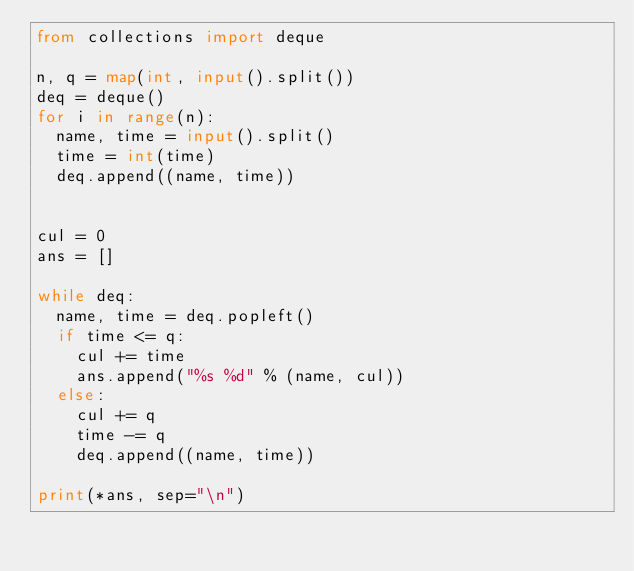Convert code to text. <code><loc_0><loc_0><loc_500><loc_500><_Python_>from collections import deque

n, q = map(int, input().split())
deq = deque()
for i in range(n):
  name, time = input().split()
  time = int(time)
  deq.append((name, time))


cul = 0
ans = []

while deq:
  name, time = deq.popleft()
  if time <= q:
    cul += time
    ans.append("%s %d" % (name, cul))
  else:
    cul += q
    time -= q
    deq.append((name, time))

print(*ans, sep="\n")
</code> 